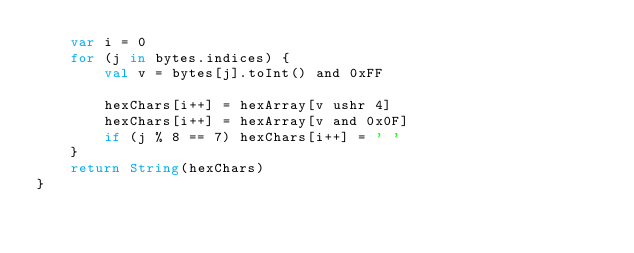Convert code to text. <code><loc_0><loc_0><loc_500><loc_500><_Kotlin_>    var i = 0
    for (j in bytes.indices) {
        val v = bytes[j].toInt() and 0xFF

        hexChars[i++] = hexArray[v ushr 4]
        hexChars[i++] = hexArray[v and 0x0F]
        if (j % 8 == 7) hexChars[i++] = ' '
    }
    return String(hexChars)
}
</code> 